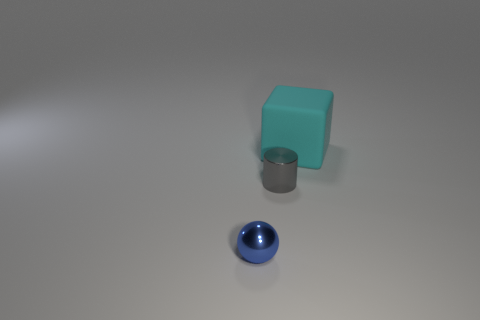Is there anything else that is the same material as the large cube? Yes, upon reviewing the image, the small cylinder appears to be made of the same material as the large cube, as they share a similar surface texture and light reflection quality. 